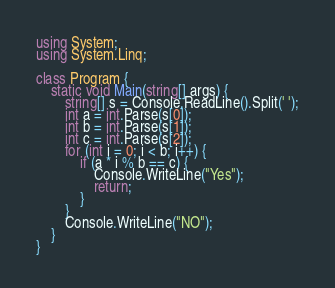Convert code to text. <code><loc_0><loc_0><loc_500><loc_500><_C#_>using System;
using System.Linq;

class Program {
    static void Main(string[] args) {
        string[] s = Console.ReadLine().Split(' ');
        int a = int.Parse(s[0]);
        int b = int.Parse(s[1]);
        int c = int.Parse(s[2]);
        for (int i = 0; i < b; i++) {
            if (a * i % b == c) {
                Console.WriteLine("Yes");
                return;
            }
        }
        Console.WriteLine("NO");
    }
}</code> 